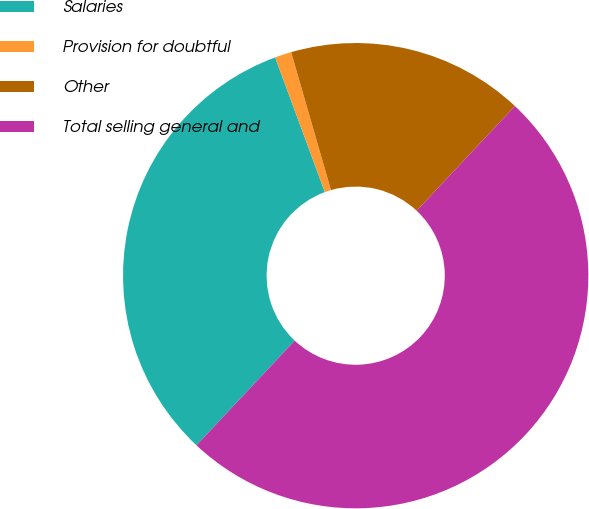Convert chart to OTSL. <chart><loc_0><loc_0><loc_500><loc_500><pie_chart><fcel>Salaries<fcel>Provision for doubtful<fcel>Other<fcel>Total selling general and<nl><fcel>32.38%<fcel>1.15%<fcel>16.47%<fcel>50.0%<nl></chart> 